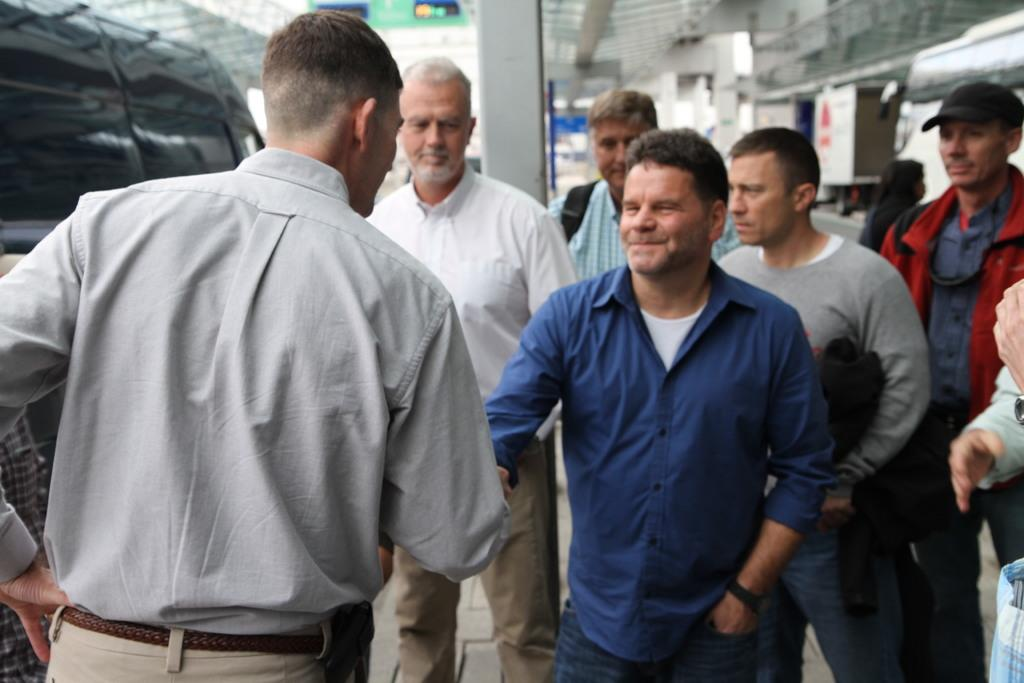What is happening between the people in the image? Two people are shaking hands in the image. How many people are present in the image? There are people standing in the image. What can be observed about the background of the image? The background of the image is blurred. What color is the orange that the tiger is holding in the image? There is no orange or tiger present in the image. 